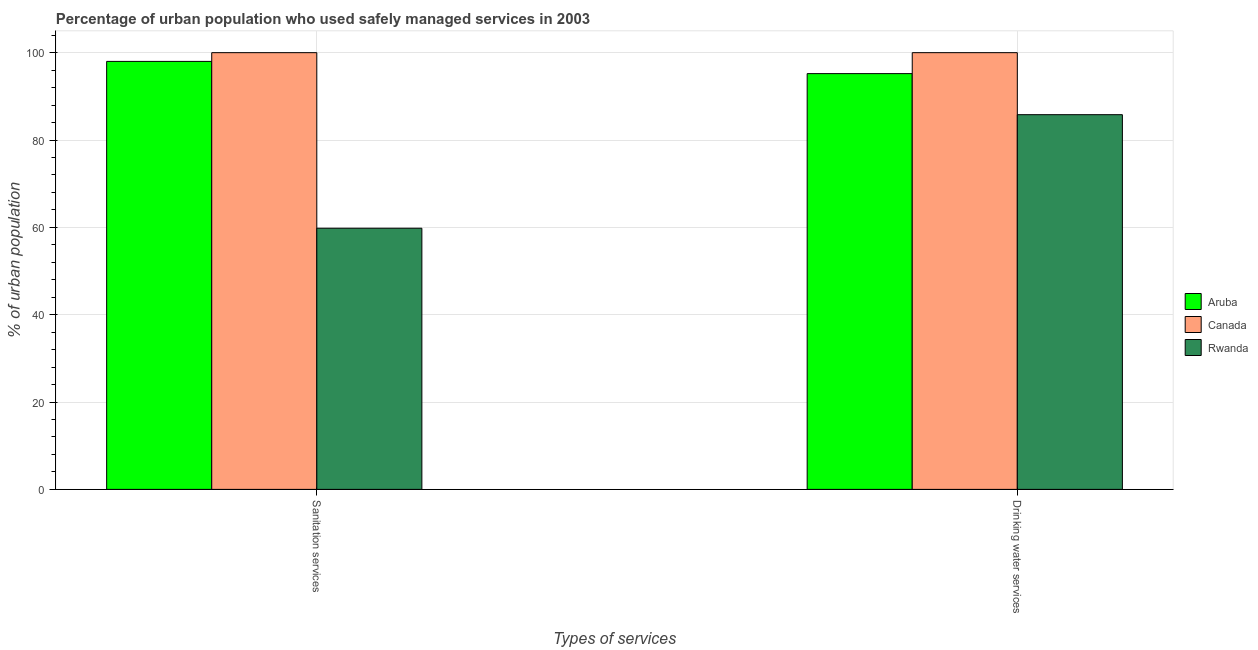How many groups of bars are there?
Provide a short and direct response. 2. Are the number of bars on each tick of the X-axis equal?
Your answer should be compact. Yes. What is the label of the 2nd group of bars from the left?
Offer a terse response. Drinking water services. What is the percentage of urban population who used sanitation services in Rwanda?
Your answer should be compact. 59.8. Across all countries, what is the maximum percentage of urban population who used drinking water services?
Offer a very short reply. 100. Across all countries, what is the minimum percentage of urban population who used drinking water services?
Make the answer very short. 85.8. In which country was the percentage of urban population who used sanitation services maximum?
Provide a succinct answer. Canada. In which country was the percentage of urban population who used sanitation services minimum?
Your response must be concise. Rwanda. What is the total percentage of urban population who used sanitation services in the graph?
Your response must be concise. 257.8. What is the difference between the percentage of urban population who used drinking water services in Aruba and that in Canada?
Offer a very short reply. -4.8. What is the difference between the percentage of urban population who used sanitation services in Aruba and the percentage of urban population who used drinking water services in Rwanda?
Your response must be concise. 12.2. What is the average percentage of urban population who used sanitation services per country?
Make the answer very short. 85.93. What is the difference between the percentage of urban population who used sanitation services and percentage of urban population who used drinking water services in Rwanda?
Your response must be concise. -26. In how many countries, is the percentage of urban population who used sanitation services greater than 36 %?
Provide a short and direct response. 3. What is the ratio of the percentage of urban population who used sanitation services in Rwanda to that in Canada?
Your response must be concise. 0.6. Is the percentage of urban population who used sanitation services in Canada less than that in Aruba?
Offer a very short reply. No. In how many countries, is the percentage of urban population who used drinking water services greater than the average percentage of urban population who used drinking water services taken over all countries?
Provide a succinct answer. 2. What does the 1st bar from the left in Sanitation services represents?
Your answer should be very brief. Aruba. What does the 2nd bar from the right in Drinking water services represents?
Offer a terse response. Canada. How many bars are there?
Give a very brief answer. 6. Are all the bars in the graph horizontal?
Offer a very short reply. No. How many countries are there in the graph?
Your answer should be very brief. 3. What is the difference between two consecutive major ticks on the Y-axis?
Provide a short and direct response. 20. Are the values on the major ticks of Y-axis written in scientific E-notation?
Your answer should be very brief. No. Does the graph contain any zero values?
Ensure brevity in your answer.  No. Where does the legend appear in the graph?
Ensure brevity in your answer.  Center right. How many legend labels are there?
Provide a succinct answer. 3. What is the title of the graph?
Keep it short and to the point. Percentage of urban population who used safely managed services in 2003. Does "Dominican Republic" appear as one of the legend labels in the graph?
Provide a short and direct response. No. What is the label or title of the X-axis?
Your answer should be compact. Types of services. What is the label or title of the Y-axis?
Your response must be concise. % of urban population. What is the % of urban population of Aruba in Sanitation services?
Provide a short and direct response. 98. What is the % of urban population in Canada in Sanitation services?
Your answer should be compact. 100. What is the % of urban population in Rwanda in Sanitation services?
Provide a succinct answer. 59.8. What is the % of urban population of Aruba in Drinking water services?
Your answer should be very brief. 95.2. What is the % of urban population of Canada in Drinking water services?
Keep it short and to the point. 100. What is the % of urban population in Rwanda in Drinking water services?
Your answer should be compact. 85.8. Across all Types of services, what is the maximum % of urban population of Aruba?
Provide a short and direct response. 98. Across all Types of services, what is the maximum % of urban population in Rwanda?
Offer a very short reply. 85.8. Across all Types of services, what is the minimum % of urban population in Aruba?
Ensure brevity in your answer.  95.2. Across all Types of services, what is the minimum % of urban population in Canada?
Your answer should be very brief. 100. Across all Types of services, what is the minimum % of urban population in Rwanda?
Ensure brevity in your answer.  59.8. What is the total % of urban population of Aruba in the graph?
Make the answer very short. 193.2. What is the total % of urban population of Canada in the graph?
Provide a succinct answer. 200. What is the total % of urban population of Rwanda in the graph?
Ensure brevity in your answer.  145.6. What is the difference between the % of urban population of Canada in Sanitation services and that in Drinking water services?
Offer a terse response. 0. What is the difference between the % of urban population of Aruba in Sanitation services and the % of urban population of Rwanda in Drinking water services?
Keep it short and to the point. 12.2. What is the difference between the % of urban population of Canada in Sanitation services and the % of urban population of Rwanda in Drinking water services?
Give a very brief answer. 14.2. What is the average % of urban population in Aruba per Types of services?
Offer a terse response. 96.6. What is the average % of urban population of Canada per Types of services?
Give a very brief answer. 100. What is the average % of urban population of Rwanda per Types of services?
Offer a very short reply. 72.8. What is the difference between the % of urban population of Aruba and % of urban population of Canada in Sanitation services?
Your answer should be very brief. -2. What is the difference between the % of urban population in Aruba and % of urban population in Rwanda in Sanitation services?
Your answer should be very brief. 38.2. What is the difference between the % of urban population in Canada and % of urban population in Rwanda in Sanitation services?
Provide a succinct answer. 40.2. What is the difference between the % of urban population in Aruba and % of urban population in Canada in Drinking water services?
Provide a short and direct response. -4.8. What is the difference between the % of urban population of Aruba and % of urban population of Rwanda in Drinking water services?
Ensure brevity in your answer.  9.4. What is the difference between the % of urban population of Canada and % of urban population of Rwanda in Drinking water services?
Provide a succinct answer. 14.2. What is the ratio of the % of urban population of Aruba in Sanitation services to that in Drinking water services?
Ensure brevity in your answer.  1.03. What is the ratio of the % of urban population of Rwanda in Sanitation services to that in Drinking water services?
Provide a short and direct response. 0.7. What is the difference between the highest and the second highest % of urban population in Canada?
Offer a terse response. 0. What is the difference between the highest and the lowest % of urban population of Rwanda?
Your answer should be very brief. 26. 